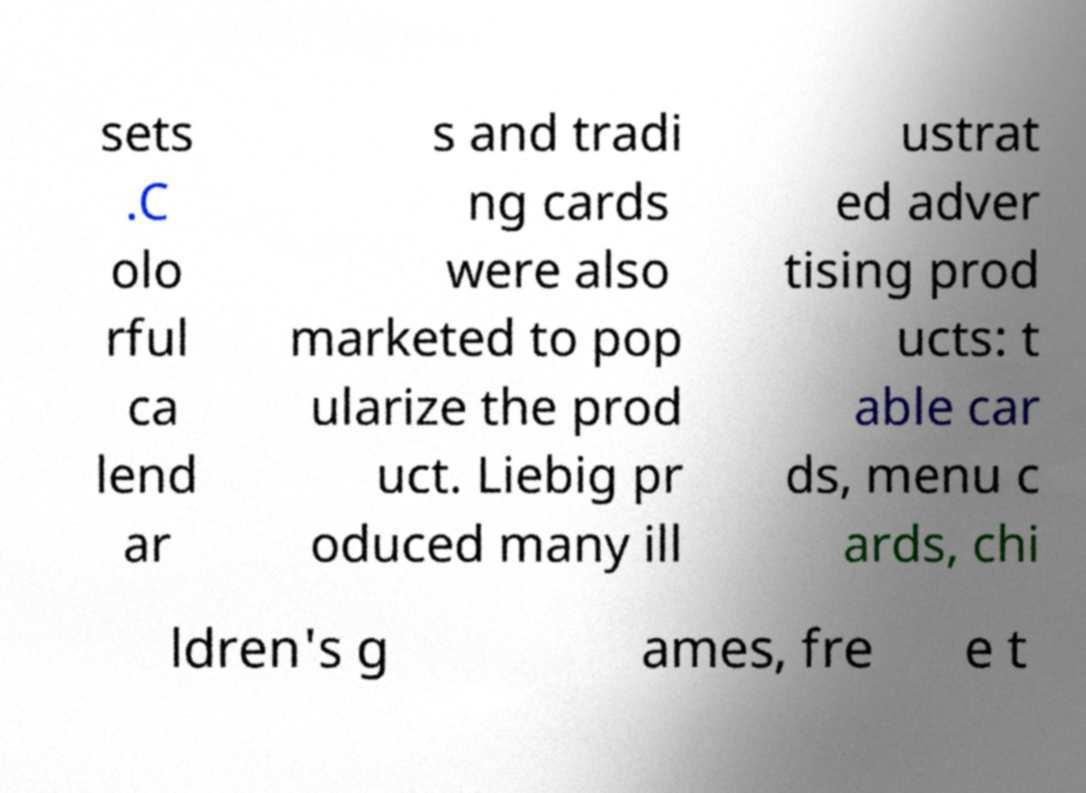For documentation purposes, I need the text within this image transcribed. Could you provide that? sets .C olo rful ca lend ar s and tradi ng cards were also marketed to pop ularize the prod uct. Liebig pr oduced many ill ustrat ed adver tising prod ucts: t able car ds, menu c ards, chi ldren's g ames, fre e t 